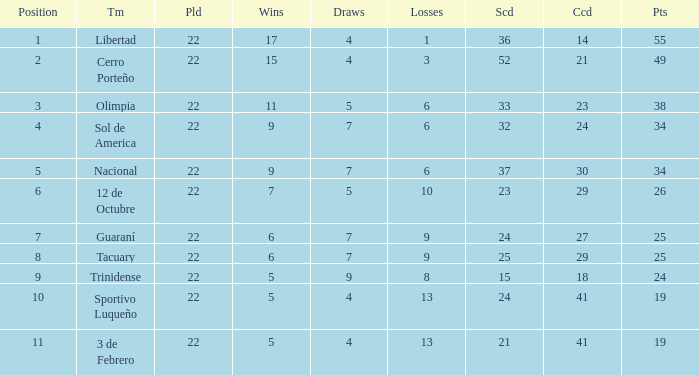What is the value scored when there were 19 points for the team 3 de Febrero? 21.0. 